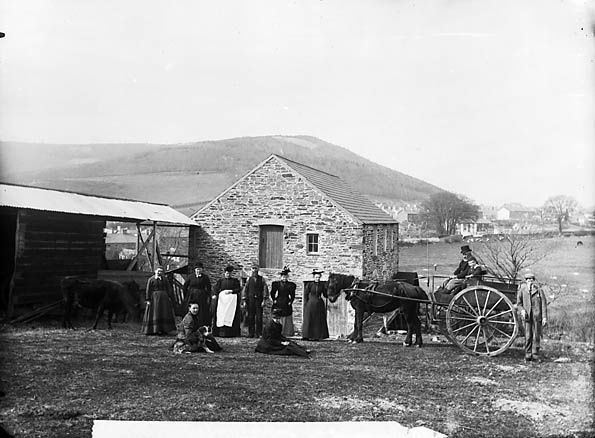Describe the objects in this image and their specific colors. I can see horse in white, black, gray, darkgray, and lightgray tones, people in white, black, gray, and lightgray tones, people in white, black, gray, darkgray, and gainsboro tones, people in white, darkgray, gray, black, and lightgray tones, and people in white, black, lightgray, gray, and darkgray tones in this image. 